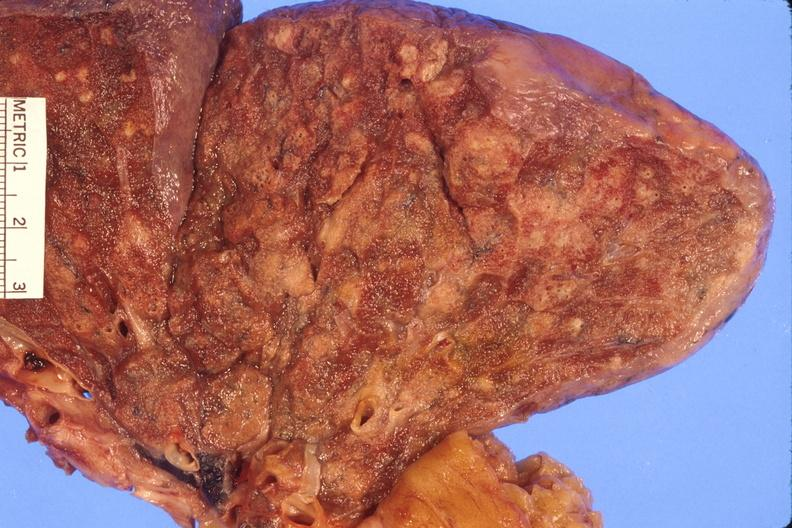does this image show lung, abscess?
Answer the question using a single word or phrase. Yes 